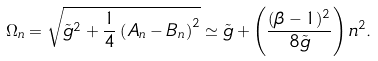Convert formula to latex. <formula><loc_0><loc_0><loc_500><loc_500>\Omega _ { n } = \sqrt { { \tilde { g } } ^ { 2 } + \frac { 1 } { 4 } \left ( A _ { n } - B _ { n } \right ) ^ { 2 } } \simeq { \tilde { g } } + \left ( \frac { ( \beta - 1 ) ^ { 2 } } { 8 { \tilde { g } } } \right ) n ^ { 2 } .</formula> 